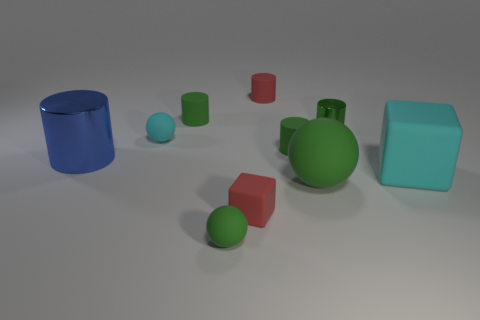There is a object that is the same color as the tiny block; what size is it?
Your answer should be compact. Small. Are there any rubber spheres of the same color as the tiny shiny cylinder?
Your answer should be compact. Yes. What shape is the small matte thing that is the same color as the large cube?
Offer a terse response. Sphere. What number of cyan things are small matte cubes or big blocks?
Your response must be concise. 1. Are the red cylinder and the big blue object made of the same material?
Your response must be concise. No. What number of cyan things are right of the tiny green matte sphere?
Your answer should be compact. 1. There is a object that is both right of the big green matte thing and behind the small cyan sphere; what is it made of?
Keep it short and to the point. Metal. What number of cylinders are tiny blue objects or large matte objects?
Keep it short and to the point. 0. What is the material of the large blue object that is the same shape as the green shiny object?
Your response must be concise. Metal. There is a cyan block that is made of the same material as the large sphere; what size is it?
Your answer should be very brief. Large. 